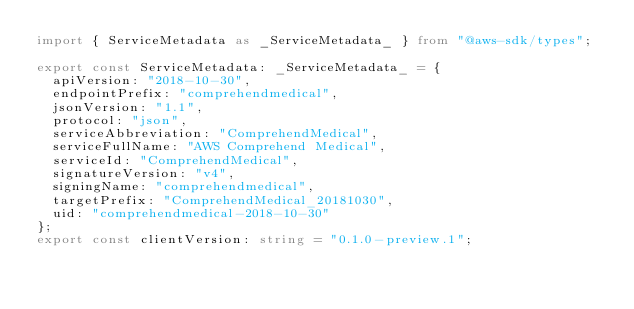Convert code to text. <code><loc_0><loc_0><loc_500><loc_500><_TypeScript_>import { ServiceMetadata as _ServiceMetadata_ } from "@aws-sdk/types";

export const ServiceMetadata: _ServiceMetadata_ = {
  apiVersion: "2018-10-30",
  endpointPrefix: "comprehendmedical",
  jsonVersion: "1.1",
  protocol: "json",
  serviceAbbreviation: "ComprehendMedical",
  serviceFullName: "AWS Comprehend Medical",
  serviceId: "ComprehendMedical",
  signatureVersion: "v4",
  signingName: "comprehendmedical",
  targetPrefix: "ComprehendMedical_20181030",
  uid: "comprehendmedical-2018-10-30"
};
export const clientVersion: string = "0.1.0-preview.1";
</code> 